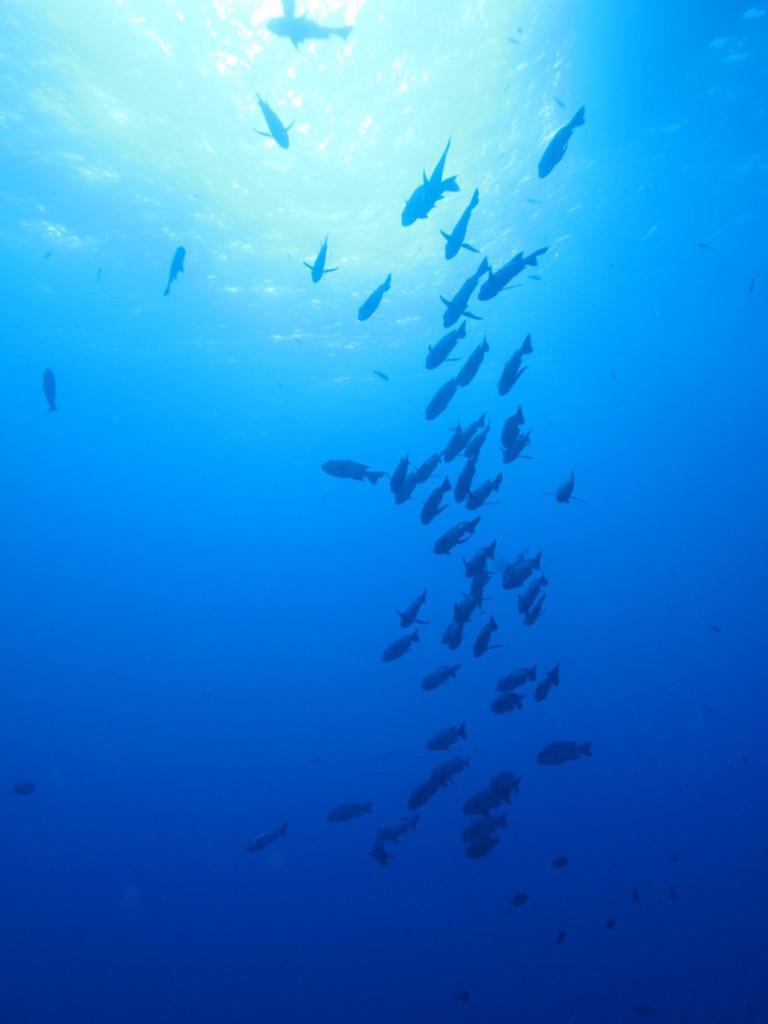Could you give a brief overview of what you see in this image? In this image we can see fishes in the water. 